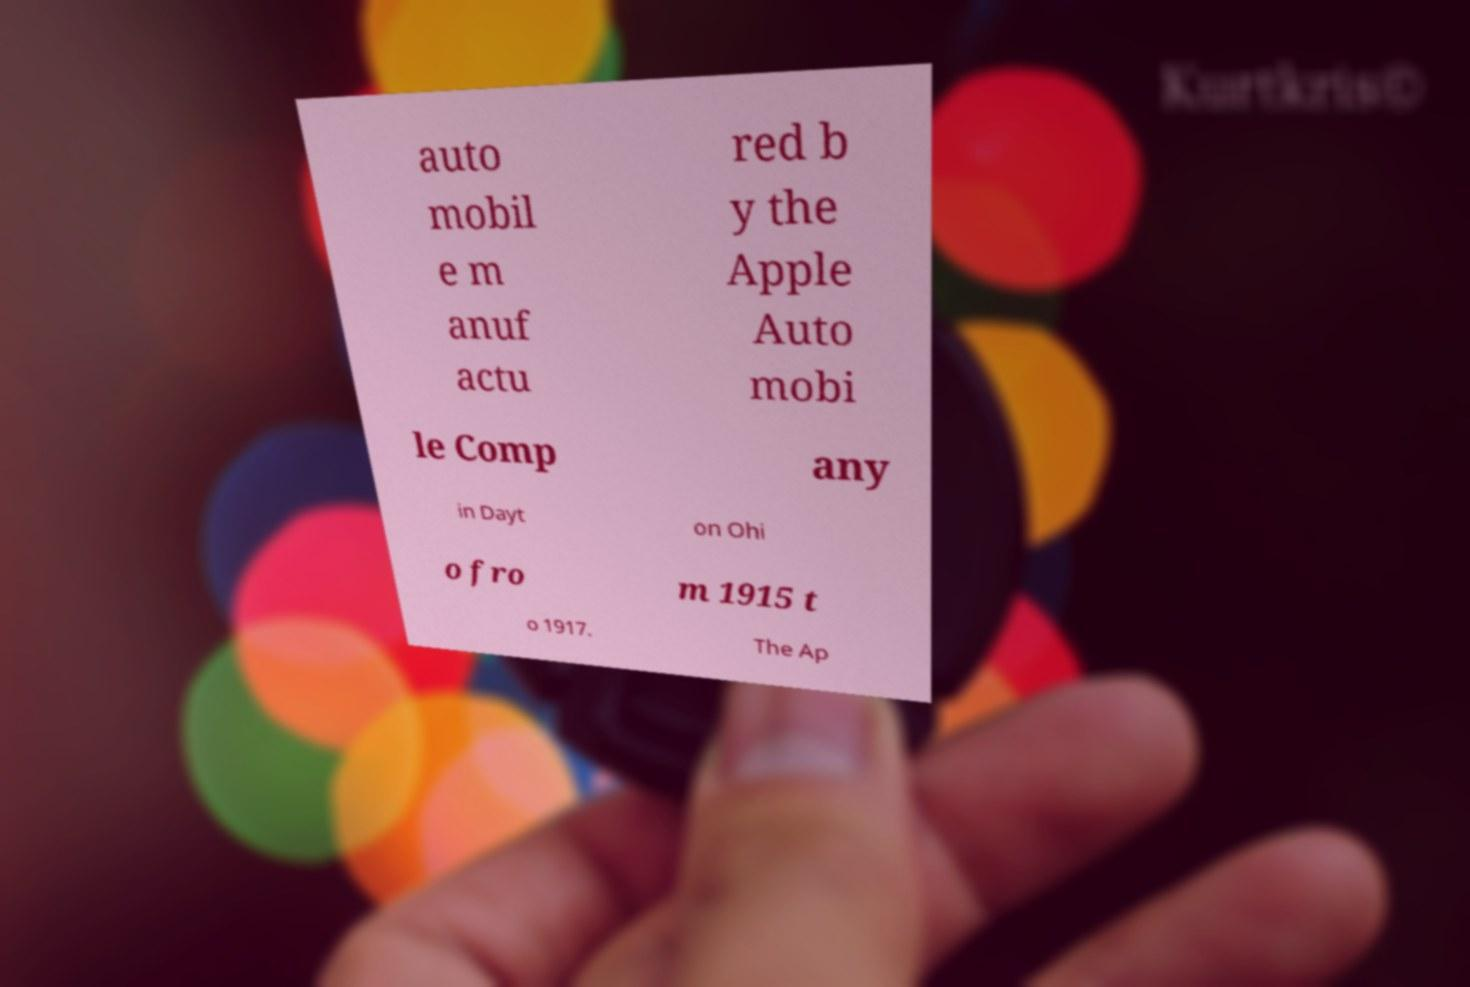For documentation purposes, I need the text within this image transcribed. Could you provide that? auto mobil e m anuf actu red b y the Apple Auto mobi le Comp any in Dayt on Ohi o fro m 1915 t o 1917. The Ap 